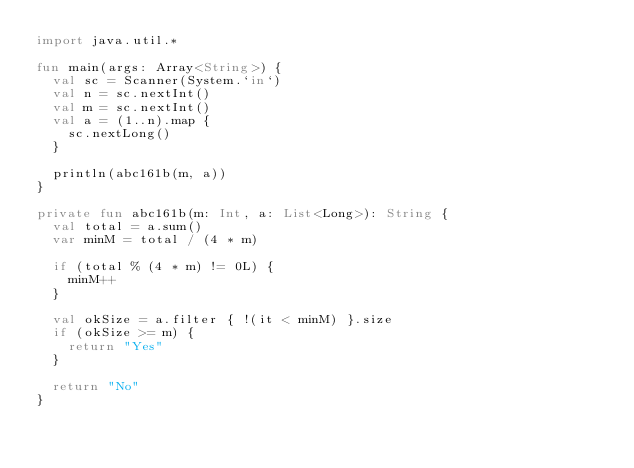Convert code to text. <code><loc_0><loc_0><loc_500><loc_500><_Kotlin_>import java.util.*

fun main(args: Array<String>) {
  val sc = Scanner(System.`in`)
  val n = sc.nextInt()
  val m = sc.nextInt()
  val a = (1..n).map {
    sc.nextLong()
  }

  println(abc161b(m, a))
}

private fun abc161b(m: Int, a: List<Long>): String {
  val total = a.sum()
  var minM = total / (4 * m)

  if (total % (4 * m) != 0L) {
    minM++
  }

  val okSize = a.filter { !(it < minM) }.size
  if (okSize >= m) {
    return "Yes"
  }

  return "No"
}
</code> 